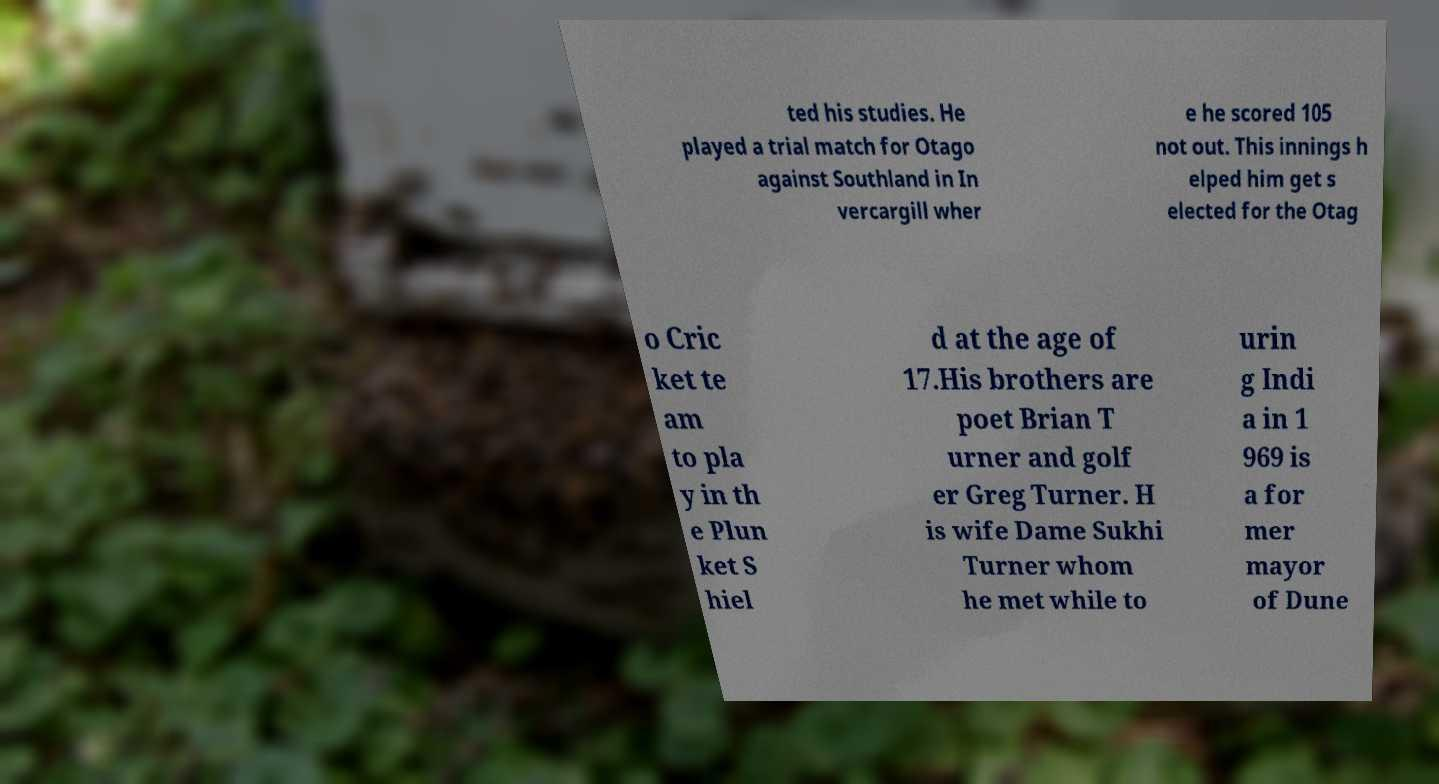What messages or text are displayed in this image? I need them in a readable, typed format. ted his studies. He played a trial match for Otago against Southland in In vercargill wher e he scored 105 not out. This innings h elped him get s elected for the Otag o Cric ket te am to pla y in th e Plun ket S hiel d at the age of 17.His brothers are poet Brian T urner and golf er Greg Turner. H is wife Dame Sukhi Turner whom he met while to urin g Indi a in 1 969 is a for mer mayor of Dune 